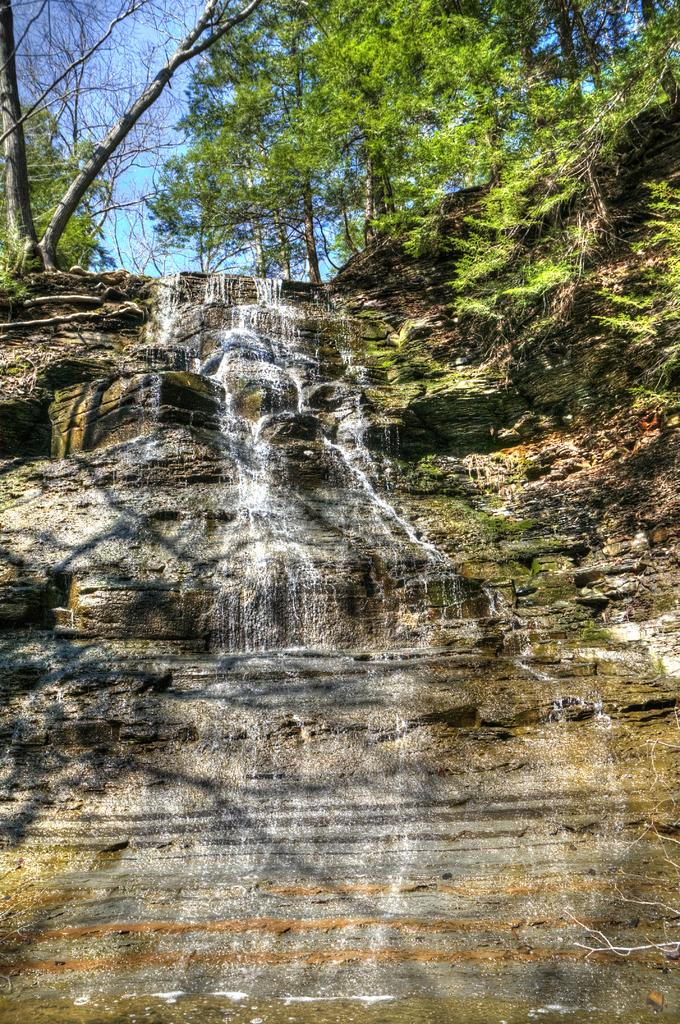What natural feature is the main subject of the image? There is a waterfall in the image. What is the source of the waterfall? The waterfall is coming from rocks. What type of vegetation can be seen in the background of the image? There are plants and trees in the background of the image. What part of the natural environment is visible in the background of the image? The sky is visible in the background of the image. What type of credit card does the aunt use to pay for the discovery in the image? There is no aunt, credit card, or discovery present in the image. 